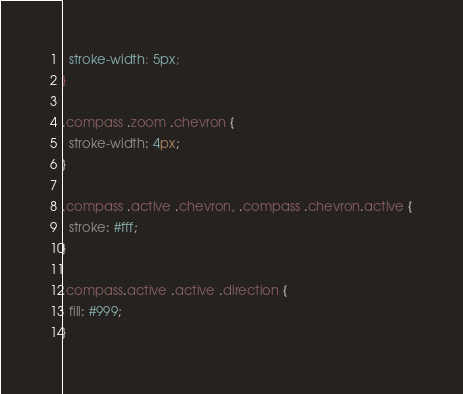<code> <loc_0><loc_0><loc_500><loc_500><_CSS_>  stroke-width: 5px;
}

.compass .zoom .chevron {
  stroke-width: 4px;
}

.compass .active .chevron, .compass .chevron.active {
  stroke: #fff;
}

.compass.active .active .direction {
  fill: #999;
}
</code> 